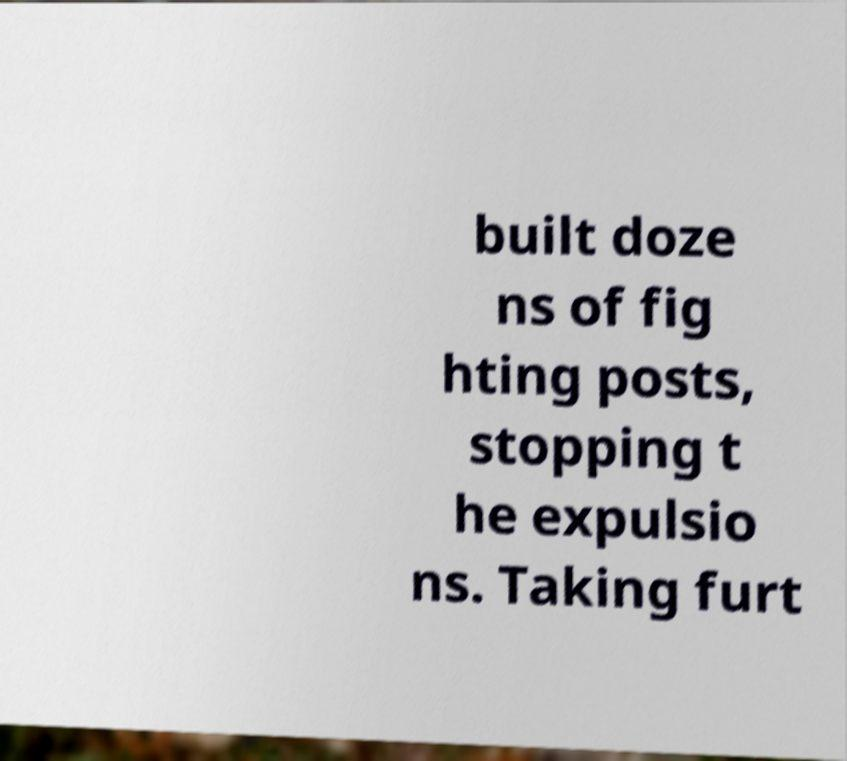Could you extract and type out the text from this image? built doze ns of fig hting posts, stopping t he expulsio ns. Taking furt 